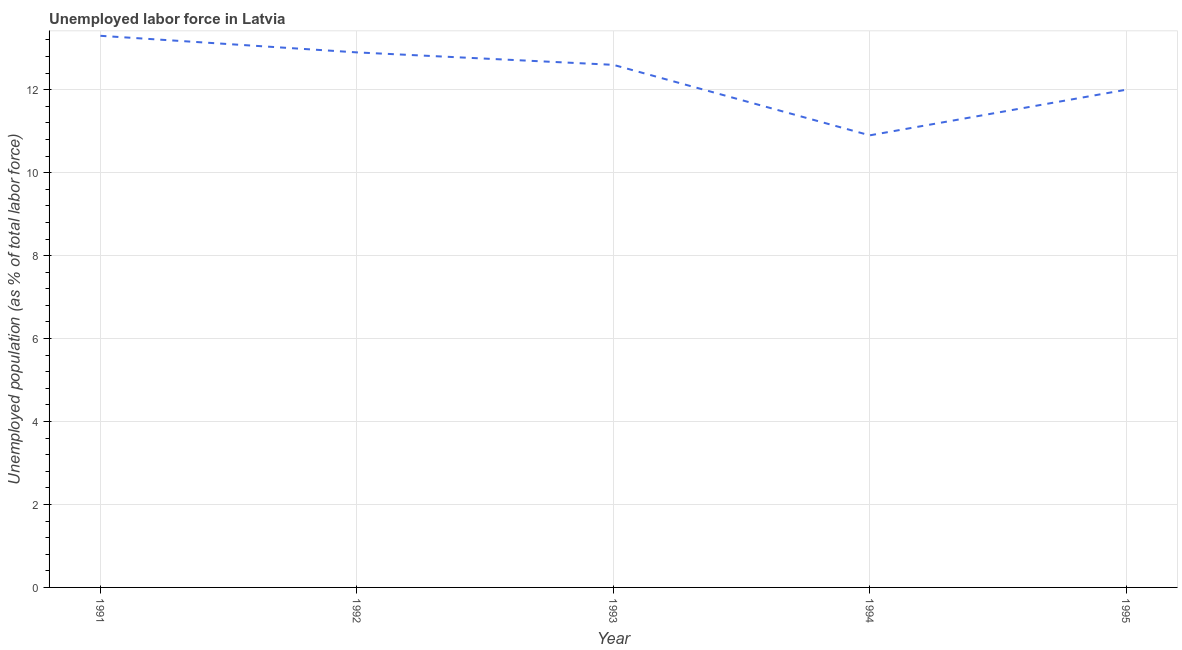Across all years, what is the maximum total unemployed population?
Offer a terse response. 13.3. Across all years, what is the minimum total unemployed population?
Offer a very short reply. 10.9. In which year was the total unemployed population maximum?
Your answer should be very brief. 1991. In which year was the total unemployed population minimum?
Provide a succinct answer. 1994. What is the sum of the total unemployed population?
Make the answer very short. 61.7. What is the difference between the total unemployed population in 1991 and 1995?
Your response must be concise. 1.3. What is the average total unemployed population per year?
Provide a short and direct response. 12.34. What is the median total unemployed population?
Give a very brief answer. 12.6. Do a majority of the years between 1995 and 1991 (inclusive) have total unemployed population greater than 8.8 %?
Your answer should be compact. Yes. What is the ratio of the total unemployed population in 1993 to that in 1995?
Make the answer very short. 1.05. Is the total unemployed population in 1992 less than that in 1993?
Offer a very short reply. No. What is the difference between the highest and the second highest total unemployed population?
Your response must be concise. 0.4. Is the sum of the total unemployed population in 1993 and 1995 greater than the maximum total unemployed population across all years?
Offer a very short reply. Yes. What is the difference between the highest and the lowest total unemployed population?
Offer a very short reply. 2.4. In how many years, is the total unemployed population greater than the average total unemployed population taken over all years?
Give a very brief answer. 3. How many lines are there?
Your answer should be compact. 1. What is the title of the graph?
Make the answer very short. Unemployed labor force in Latvia. What is the label or title of the Y-axis?
Give a very brief answer. Unemployed population (as % of total labor force). What is the Unemployed population (as % of total labor force) of 1991?
Keep it short and to the point. 13.3. What is the Unemployed population (as % of total labor force) in 1992?
Give a very brief answer. 12.9. What is the Unemployed population (as % of total labor force) of 1993?
Your answer should be very brief. 12.6. What is the Unemployed population (as % of total labor force) of 1994?
Offer a very short reply. 10.9. What is the difference between the Unemployed population (as % of total labor force) in 1991 and 1992?
Your response must be concise. 0.4. What is the difference between the Unemployed population (as % of total labor force) in 1991 and 1993?
Provide a succinct answer. 0.7. What is the difference between the Unemployed population (as % of total labor force) in 1991 and 1994?
Your answer should be compact. 2.4. What is the difference between the Unemployed population (as % of total labor force) in 1991 and 1995?
Your answer should be compact. 1.3. What is the difference between the Unemployed population (as % of total labor force) in 1992 and 1993?
Give a very brief answer. 0.3. What is the difference between the Unemployed population (as % of total labor force) in 1992 and 1995?
Your answer should be very brief. 0.9. What is the difference between the Unemployed population (as % of total labor force) in 1993 and 1994?
Your answer should be very brief. 1.7. What is the ratio of the Unemployed population (as % of total labor force) in 1991 to that in 1992?
Provide a succinct answer. 1.03. What is the ratio of the Unemployed population (as % of total labor force) in 1991 to that in 1993?
Your response must be concise. 1.06. What is the ratio of the Unemployed population (as % of total labor force) in 1991 to that in 1994?
Your answer should be compact. 1.22. What is the ratio of the Unemployed population (as % of total labor force) in 1991 to that in 1995?
Provide a succinct answer. 1.11. What is the ratio of the Unemployed population (as % of total labor force) in 1992 to that in 1993?
Your response must be concise. 1.02. What is the ratio of the Unemployed population (as % of total labor force) in 1992 to that in 1994?
Keep it short and to the point. 1.18. What is the ratio of the Unemployed population (as % of total labor force) in 1992 to that in 1995?
Offer a very short reply. 1.07. What is the ratio of the Unemployed population (as % of total labor force) in 1993 to that in 1994?
Keep it short and to the point. 1.16. What is the ratio of the Unemployed population (as % of total labor force) in 1993 to that in 1995?
Offer a very short reply. 1.05. What is the ratio of the Unemployed population (as % of total labor force) in 1994 to that in 1995?
Ensure brevity in your answer.  0.91. 